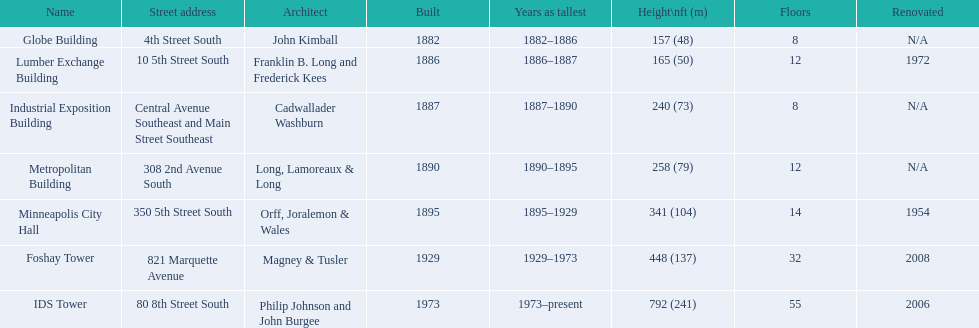What are the heights of the buildings? 157 (48), 165 (50), 240 (73), 258 (79), 341 (104), 448 (137), 792 (241). What building is 240 ft tall? Industrial Exposition Building. 